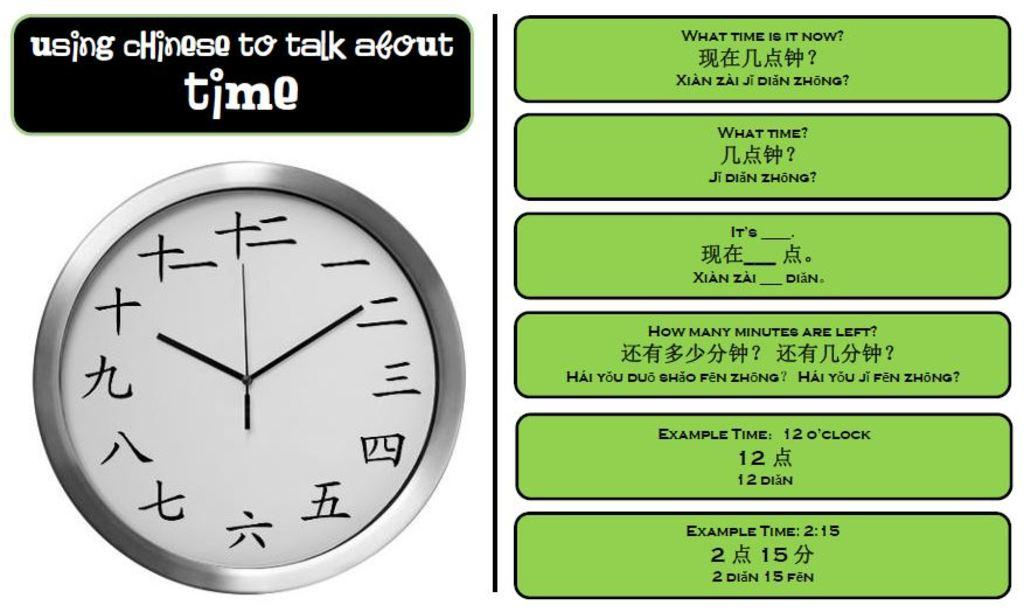<image>
Relay a brief, clear account of the picture shown. A clock has a sign above it and green boxes to the side showing example times. 